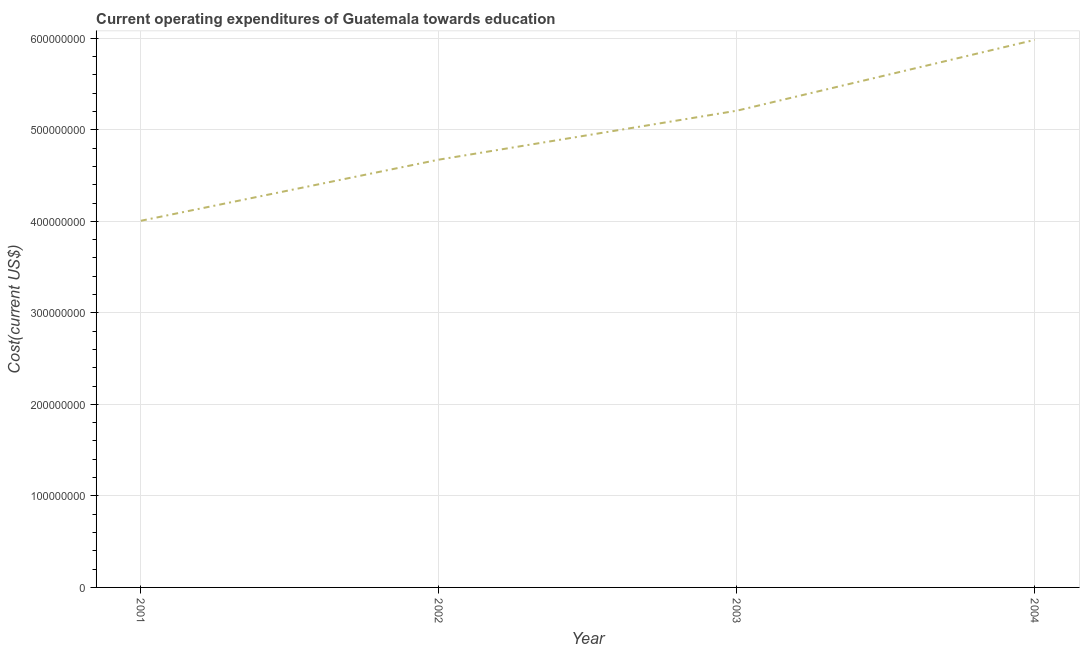What is the education expenditure in 2001?
Ensure brevity in your answer.  4.01e+08. Across all years, what is the maximum education expenditure?
Your answer should be very brief. 5.98e+08. Across all years, what is the minimum education expenditure?
Provide a short and direct response. 4.01e+08. In which year was the education expenditure maximum?
Give a very brief answer. 2004. What is the sum of the education expenditure?
Make the answer very short. 1.99e+09. What is the difference between the education expenditure in 2002 and 2004?
Your response must be concise. -1.31e+08. What is the average education expenditure per year?
Provide a short and direct response. 4.97e+08. What is the median education expenditure?
Your response must be concise. 4.94e+08. In how many years, is the education expenditure greater than 480000000 US$?
Offer a terse response. 2. What is the ratio of the education expenditure in 2001 to that in 2002?
Make the answer very short. 0.86. What is the difference between the highest and the second highest education expenditure?
Offer a terse response. 7.74e+07. Is the sum of the education expenditure in 2001 and 2003 greater than the maximum education expenditure across all years?
Provide a succinct answer. Yes. What is the difference between the highest and the lowest education expenditure?
Offer a terse response. 1.98e+08. How many lines are there?
Your response must be concise. 1. What is the difference between two consecutive major ticks on the Y-axis?
Offer a terse response. 1.00e+08. Does the graph contain any zero values?
Offer a terse response. No. Does the graph contain grids?
Your response must be concise. Yes. What is the title of the graph?
Provide a succinct answer. Current operating expenditures of Guatemala towards education. What is the label or title of the X-axis?
Provide a succinct answer. Year. What is the label or title of the Y-axis?
Provide a succinct answer. Cost(current US$). What is the Cost(current US$) of 2001?
Your answer should be very brief. 4.01e+08. What is the Cost(current US$) in 2002?
Your answer should be compact. 4.67e+08. What is the Cost(current US$) in 2003?
Offer a very short reply. 5.21e+08. What is the Cost(current US$) in 2004?
Offer a very short reply. 5.98e+08. What is the difference between the Cost(current US$) in 2001 and 2002?
Make the answer very short. -6.68e+07. What is the difference between the Cost(current US$) in 2001 and 2003?
Your answer should be compact. -1.20e+08. What is the difference between the Cost(current US$) in 2001 and 2004?
Provide a short and direct response. -1.98e+08. What is the difference between the Cost(current US$) in 2002 and 2003?
Offer a terse response. -5.35e+07. What is the difference between the Cost(current US$) in 2002 and 2004?
Keep it short and to the point. -1.31e+08. What is the difference between the Cost(current US$) in 2003 and 2004?
Your answer should be very brief. -7.74e+07. What is the ratio of the Cost(current US$) in 2001 to that in 2002?
Your response must be concise. 0.86. What is the ratio of the Cost(current US$) in 2001 to that in 2003?
Provide a succinct answer. 0.77. What is the ratio of the Cost(current US$) in 2001 to that in 2004?
Make the answer very short. 0.67. What is the ratio of the Cost(current US$) in 2002 to that in 2003?
Provide a short and direct response. 0.9. What is the ratio of the Cost(current US$) in 2002 to that in 2004?
Make the answer very short. 0.78. What is the ratio of the Cost(current US$) in 2003 to that in 2004?
Offer a terse response. 0.87. 